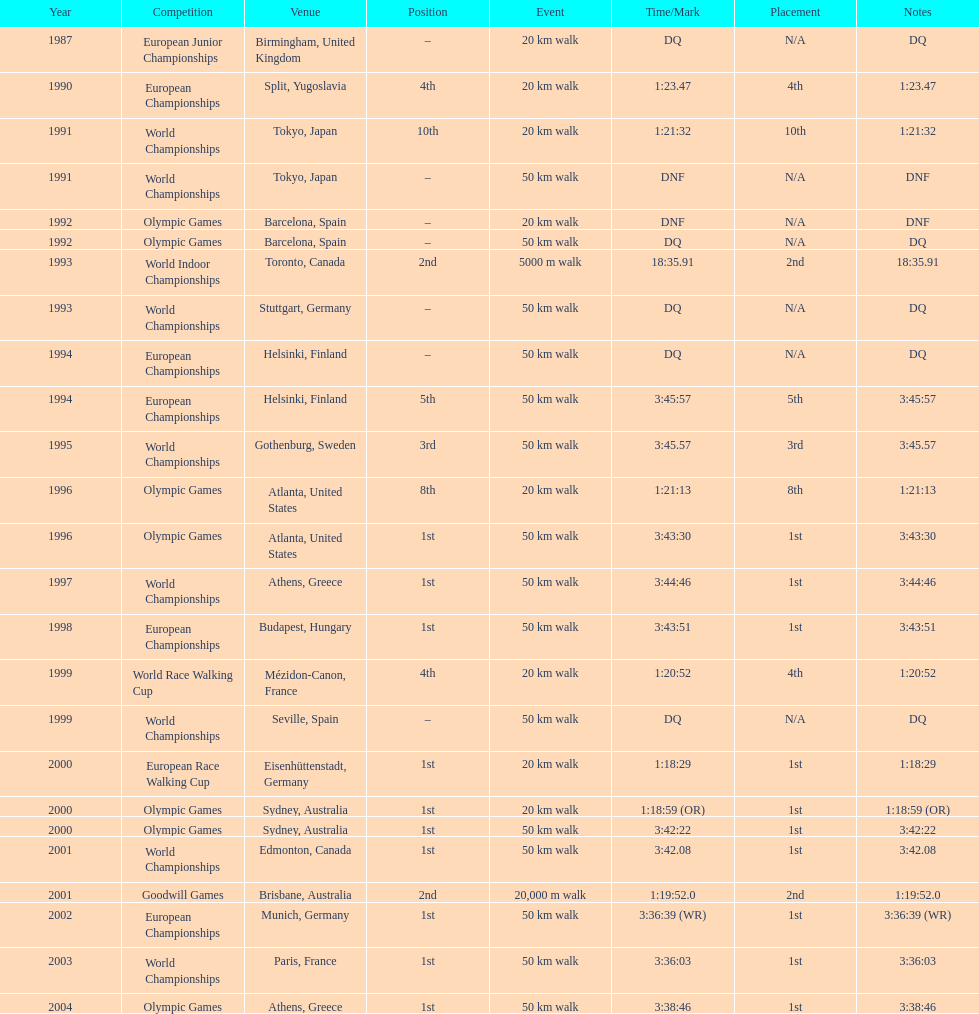In how many occasions did korzeniowski end up in a position better than fourth place? 13. 